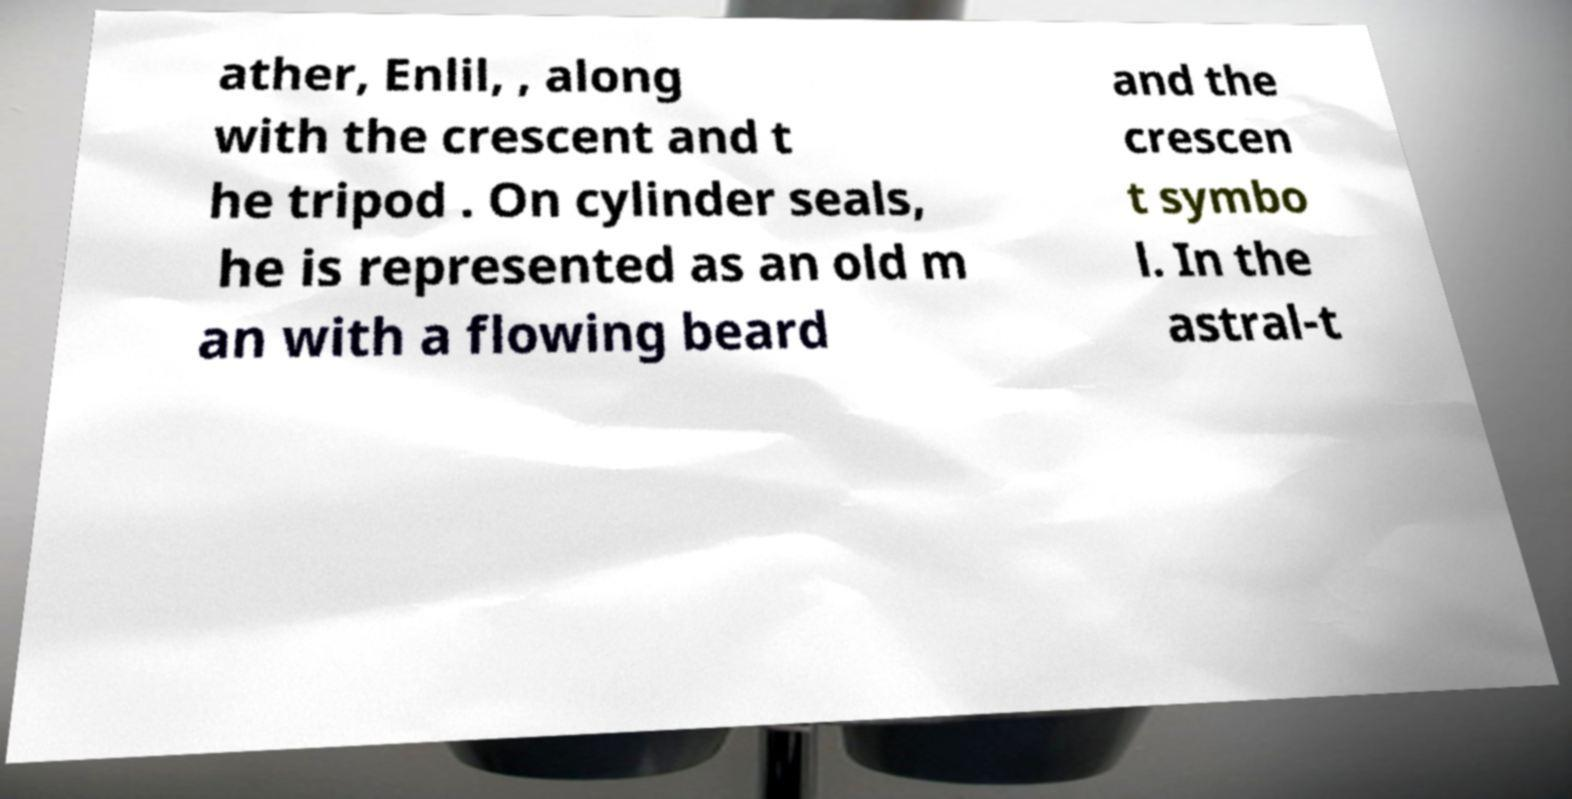Please read and relay the text visible in this image. What does it say? ather, Enlil, , along with the crescent and t he tripod . On cylinder seals, he is represented as an old m an with a flowing beard and the crescen t symbo l. In the astral-t 